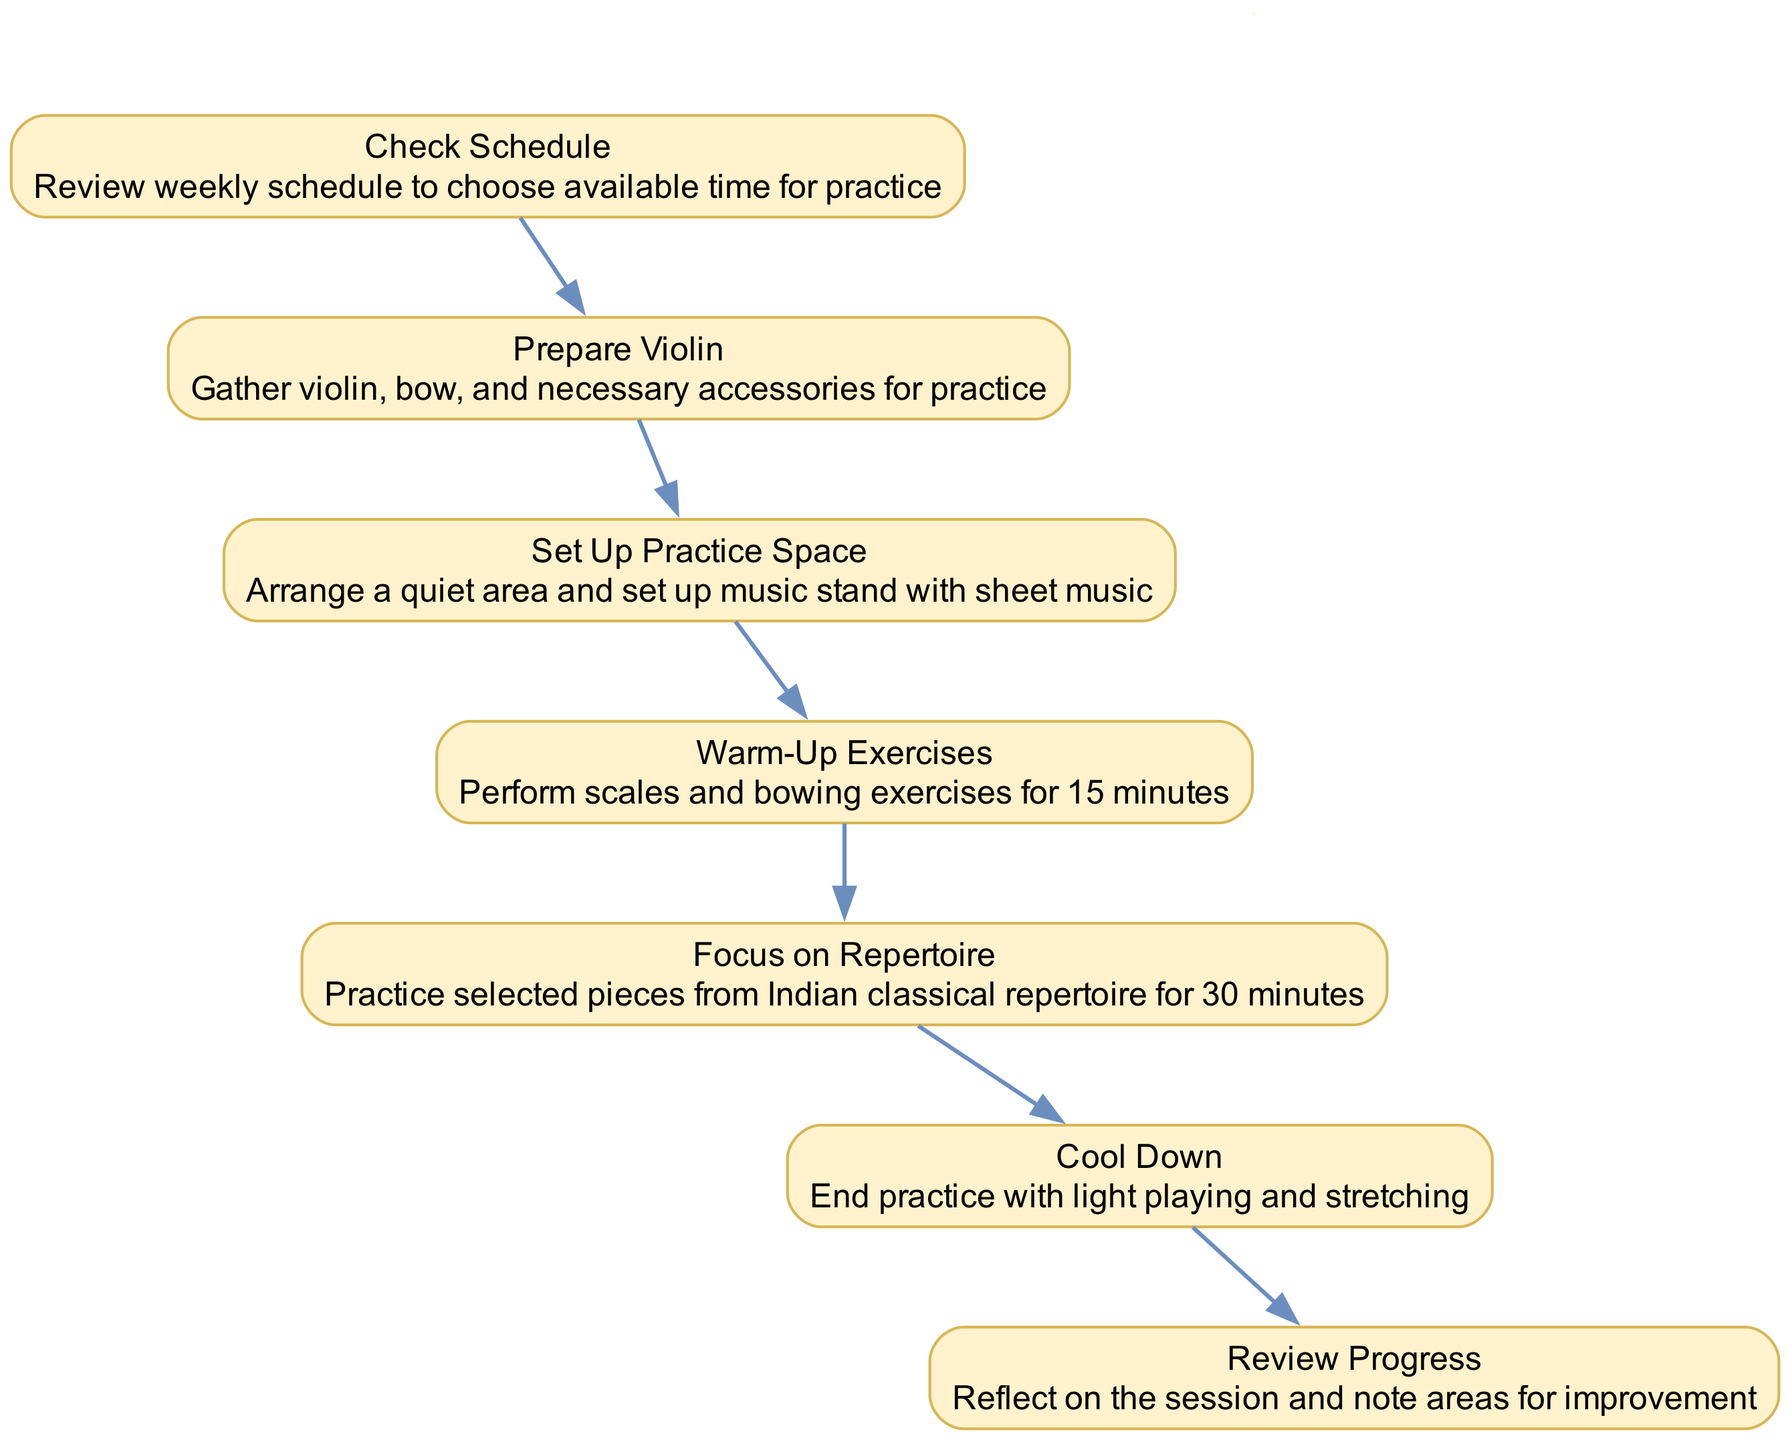What is the first activity in the practice session? The first activity listed in the diagram is "Check Schedule." It is indicated as the starting point of the flow in the sequence diagram.
Answer: Check Schedule How many activities are there in total? The diagram contains a total of 7 activities that the violinist needs to perform for the practice session, enumerating each step in the sequence.
Answer: 7 What follows "Prepare Violin" in the sequence? The activity that follows "Prepare Violin" is "Set Up Practice Space." This can be determined by visually following the arrows in the flow of the diagram.
Answer: Set Up Practice Space What is the duration of the "Warm-Up Exercises"? The “Warm-Up Exercises” activity is specified to take 15 minutes, as mentioned in the description associated with that node in the sequence diagram.
Answer: 15 minutes What is the last activity in the practice session? The last activity depicted in the sequence diagram is "Review Progress," which concludes the flow of activities in the practice session.
Answer: Review Progress Which two activities are separated by "Focus on Repertoire"? "Warm-Up Exercises" occurs before and "Cool Down" follows after "Focus on Repertoire." This relationship can be traced by examining the sequence of nodes and their connections.
Answer: Warm-Up Exercises and Cool Down What is the relationship between "Review Progress" and "Warm-Up Exercises"? There is a sequential flow from "Warm-Up Exercises" to "Focus on Repertoire" leading up to "Review Progress." They are connected through the overall practice structure but separated by two other activities.
Answer: Sequential flow Which activity is performed immediately after "Set Up Practice Space"? The activity that comes immediately after "Set Up Practice Space" is "Warm-Up Exercises," indicating a direct transition in the sequence diagram.
Answer: Warm-Up Exercises 